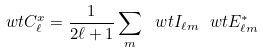Convert formula to latex. <formula><loc_0><loc_0><loc_500><loc_500>\ w t { C } _ { \ell } ^ { x } = \frac { 1 } { 2 \ell + 1 } \sum _ { m } \ w t { I } _ { \ell m } \ w t { E } _ { \ell m } ^ { * }</formula> 